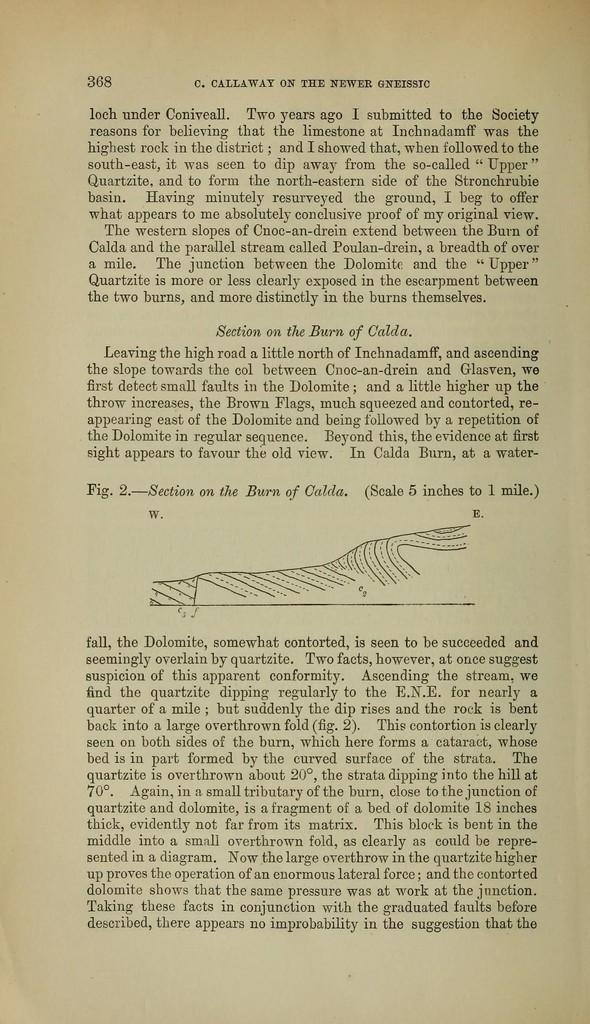<image>
Provide a brief description of the given image. Page 368 of the book C. Callaway on the newer gneissic. 